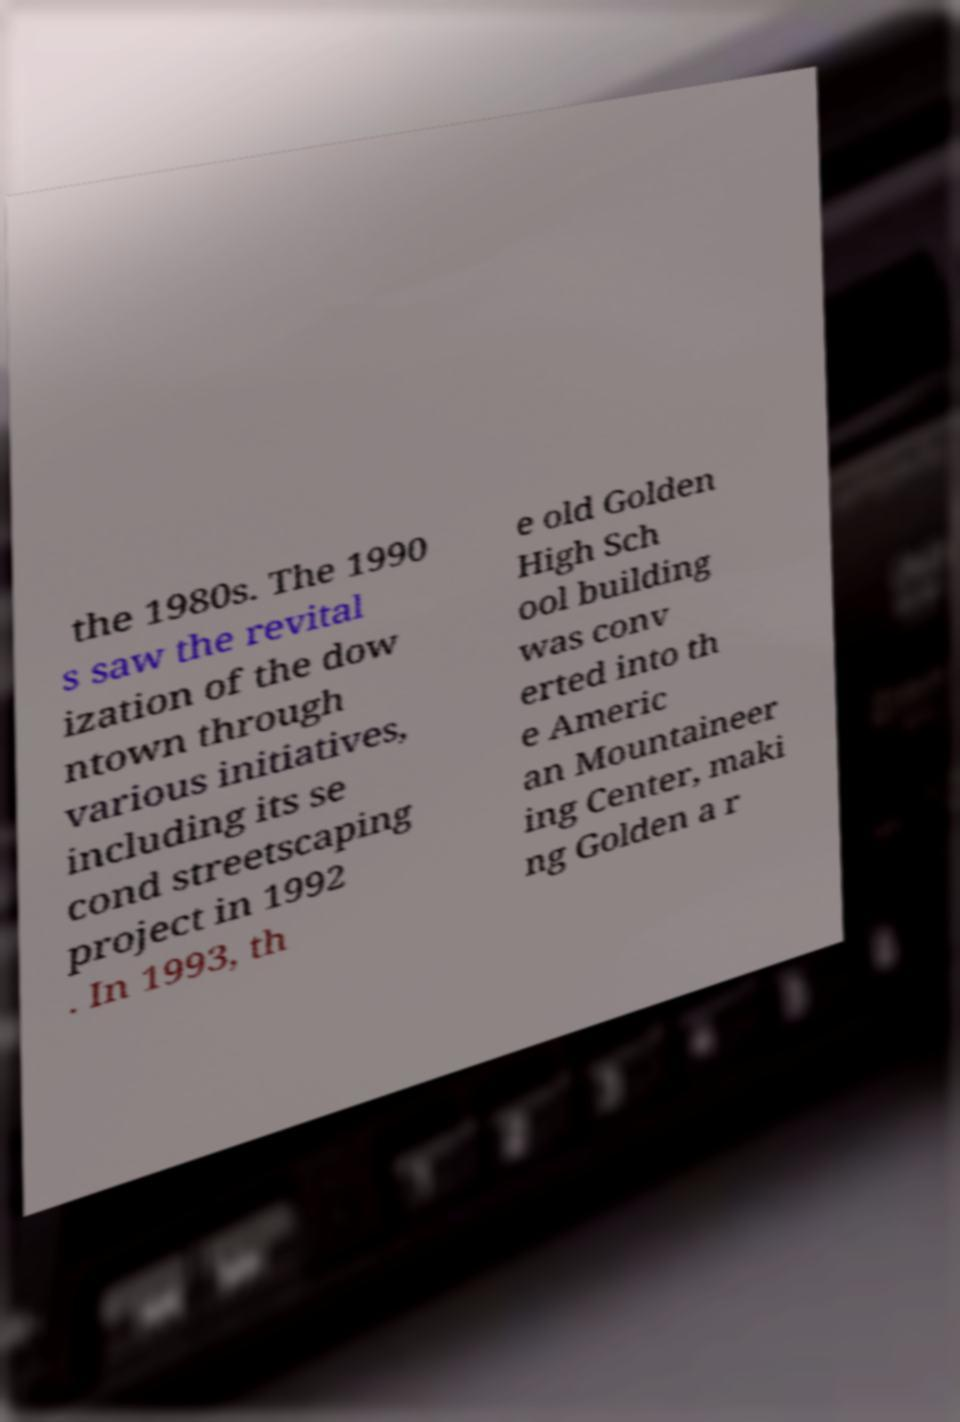I need the written content from this picture converted into text. Can you do that? the 1980s. The 1990 s saw the revital ization of the dow ntown through various initiatives, including its se cond streetscaping project in 1992 . In 1993, th e old Golden High Sch ool building was conv erted into th e Americ an Mountaineer ing Center, maki ng Golden a r 